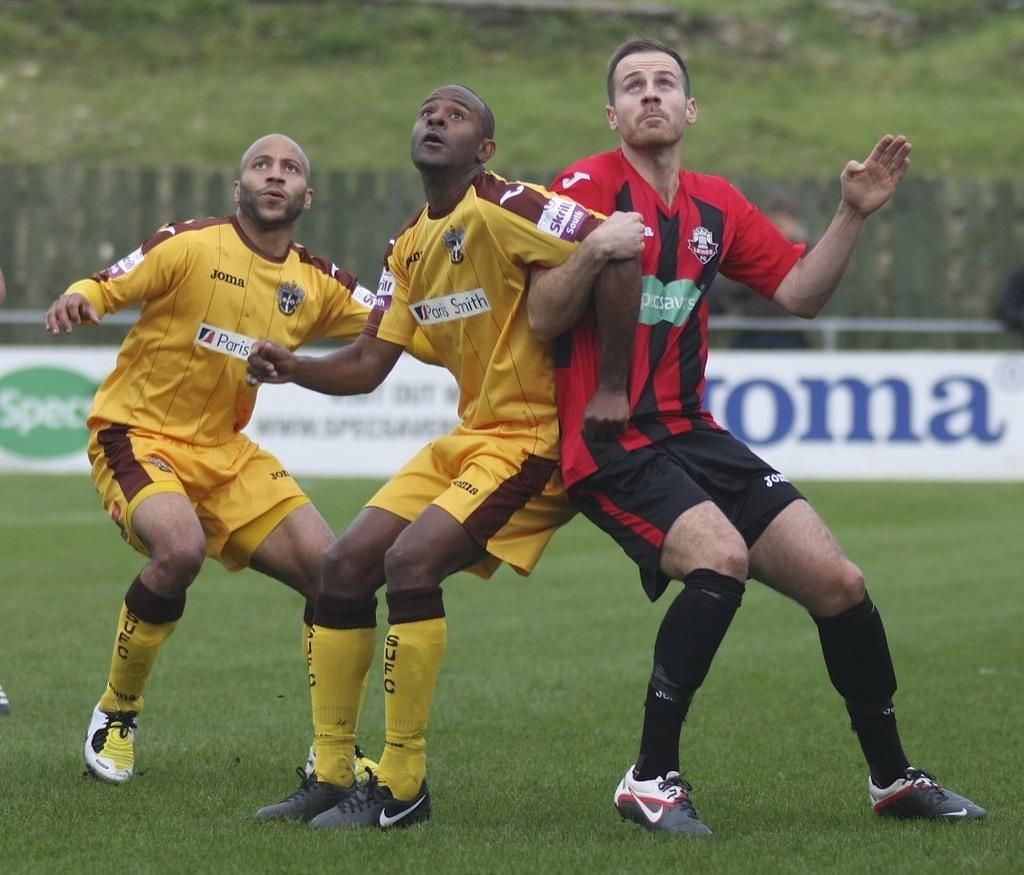<image>
Share a concise interpretation of the image provided. One football team is sponsored by specsavers, the other by Paris Smith. 